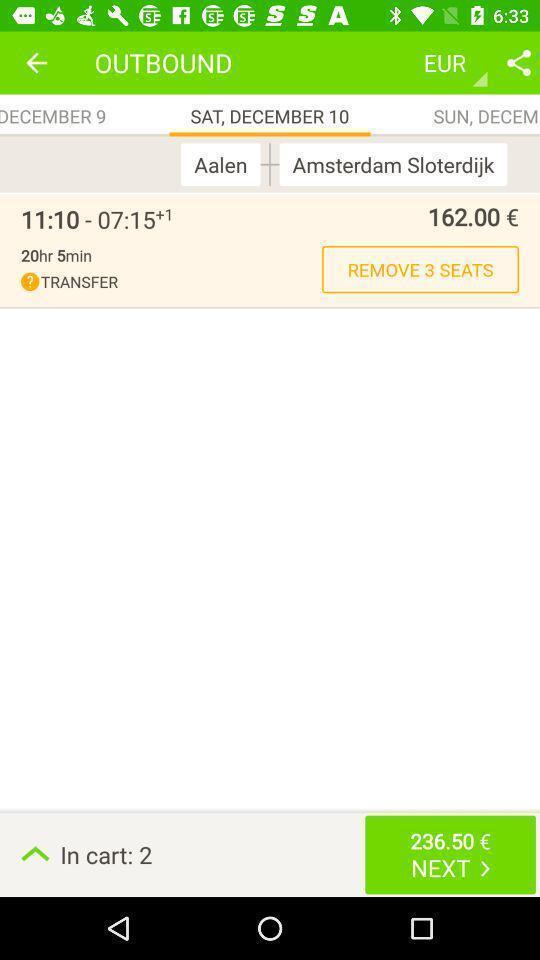Please provide a description for this image. Page showing prices in a travel application. 